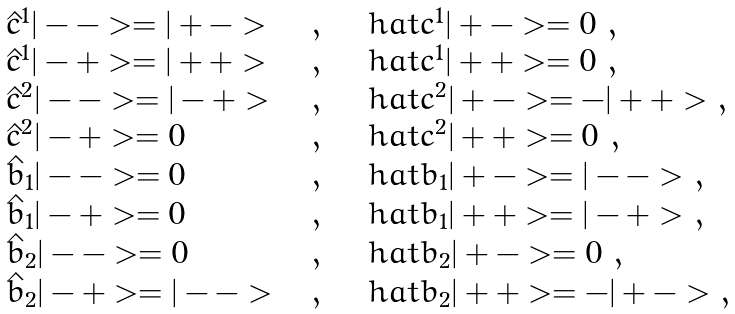Convert formula to latex. <formula><loc_0><loc_0><loc_500><loc_500>\begin{array} { l c l } \hat { c } ^ { 1 } | - - > = | + - > \ \ & , & \quad h a t { c } ^ { 1 } | + - > = 0 \ , \\ \hat { c } ^ { 1 } | - + > = | + + > \ \ & , & \quad h a t { c } ^ { 1 } | + + > = 0 \ , \\ \hat { c } ^ { 2 } | - - > = | - + > \ \ & , & \quad h a t { c } ^ { 2 } | + - > = - | + + > \ , \\ \hat { c } ^ { 2 } | - + > = 0 \ \ & , & \quad h a t { c } ^ { 2 } | + + > = 0 \ , \\ \hat { b } _ { 1 } | - - > = 0 \ \ & , & \quad h a t { b } _ { 1 } | + - > = | - - > \ , \\ \hat { b } _ { 1 } | - + > = 0 \ \ & , & \quad h a t { b } _ { 1 } | + + > = | - + > \ , \\ \hat { b } _ { 2 } | - - > = 0 \ \ & , & \quad h a t { b } _ { 2 } | + - > = 0 \ , \\ \hat { b } _ { 2 } | - + > = | - - > \ \ & , & \quad h a t { b } _ { 2 } | + + > = - | + - > \ , \end{array}</formula> 